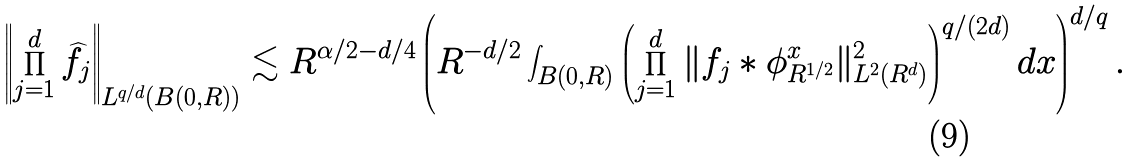<formula> <loc_0><loc_0><loc_500><loc_500>\left \| \prod _ { j = 1 } ^ { d } \widehat { f } _ { j } \right \| _ { L ^ { q / d } ( B ( 0 , R ) ) } \lesssim R ^ { \alpha / 2 - d / 4 } \left ( R ^ { - d / 2 } \int _ { B ( 0 , R ) } \left ( \prod _ { j = 1 } ^ { d } \| f _ { j } * \phi _ { R ^ { 1 / 2 } } ^ { x } \| _ { L ^ { 2 } ( { R } ^ { d } ) } ^ { 2 } \right ) ^ { q / ( 2 d ) } d x \right ) ^ { d / q } .</formula> 